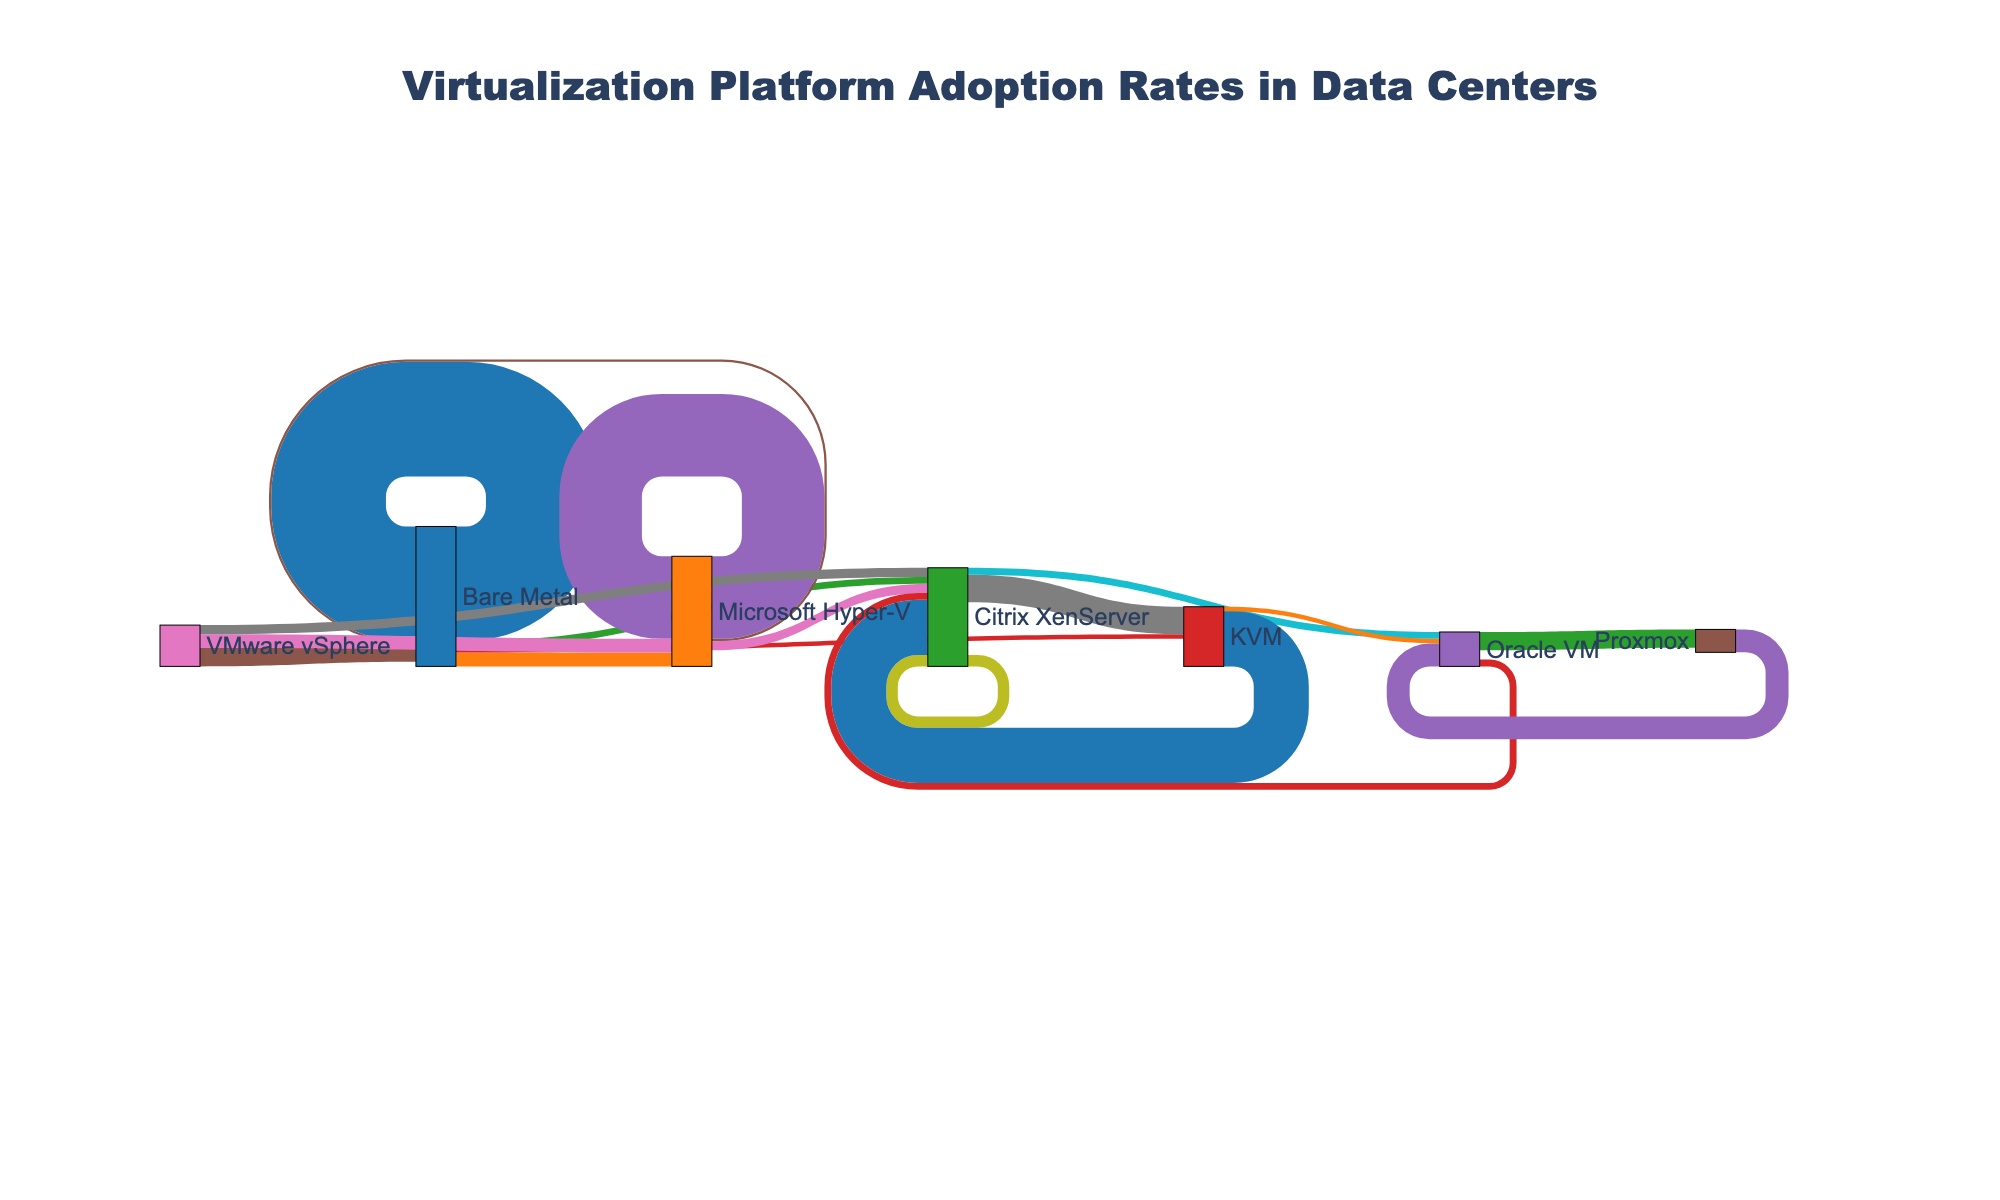What is the title of the Sankey Diagram? The title can be found at the top of the diagram, which clearly indicates the subject of the visualization.
Answer: Virtualization Platform Adoption Rates in Data Centers How many platforms transition from Bare Metal to any hypervisor? To find the number of platforms that transition from Bare Metal, count the outgoing links from the Bare Metal node.
Answer: 3 Which hypervisor received the most transitions from VMware vSphere? By looking at the outgoing links from the VMware vSphere node and identifying the link with the highest value, you can determine the target with the most transitions.
Answer: Microsoft Hyper-V How many transitions involve Citrix XenServer as either a source or a target? Count all the links where Citrix XenServer appears either as a source or target, and sum these counts.
Answer: 4 Which hypervisor has the highest count of self-transition, and what is that count? Identify the node with the highest value for transitions that start and end at the same node.
Answer: VMware vSphere, 250 What is the combined value of transitions from Microsoft Hyper-V to other hypervisors? Sum the values of the links originating from Microsoft Hyper-V and targeting other hypervisors.
Answer: 25 Compare the adoption rate transitions from Bare Metal to VMware vSphere and Microsoft Hyper-V. Which is higher? Compare the link values for transitions from Bare Metal to those two hypervisors and see which one is higher.
Answer: VMware vSphere What is the total value of transitions towards KVM? Sum all the values where KVM is the target node from any source.
Answer: 95 Is the value of transitions from VMware vSphere to KVM higher or lower than the value of transitions from Microsoft Hyper-V to KVM? Compare the link values from VMware vSphere to KVM and Microsoft Hyper-V to KVM.
Answer: Lower Which node acts as both a source and a target, excluding self-transitions, in the most number of transitions? Count how many times each node appears as both a source and a target in different links, excluding self-transitions.
Answer: KVM 